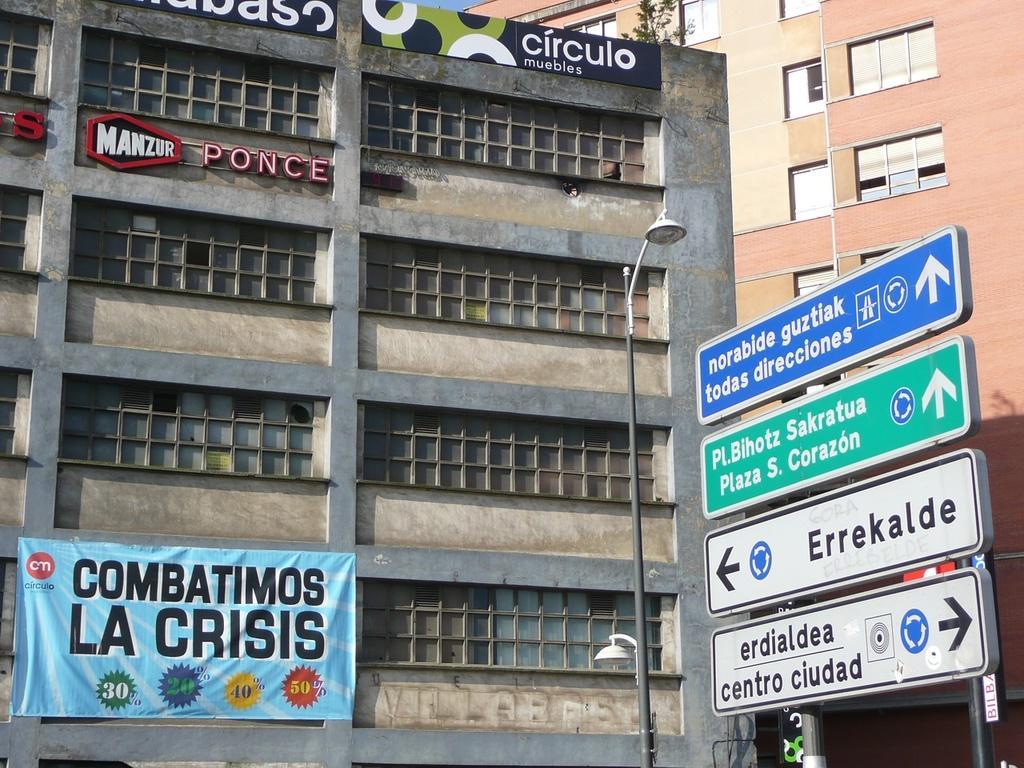Describe this image in one or two sentences. In this image I can see the boards and the light pole. To the left there is a banner attached to the building. To the right I can see one more building which is in brown and cream color. And there are windows to it. In the back I can see the sky. 